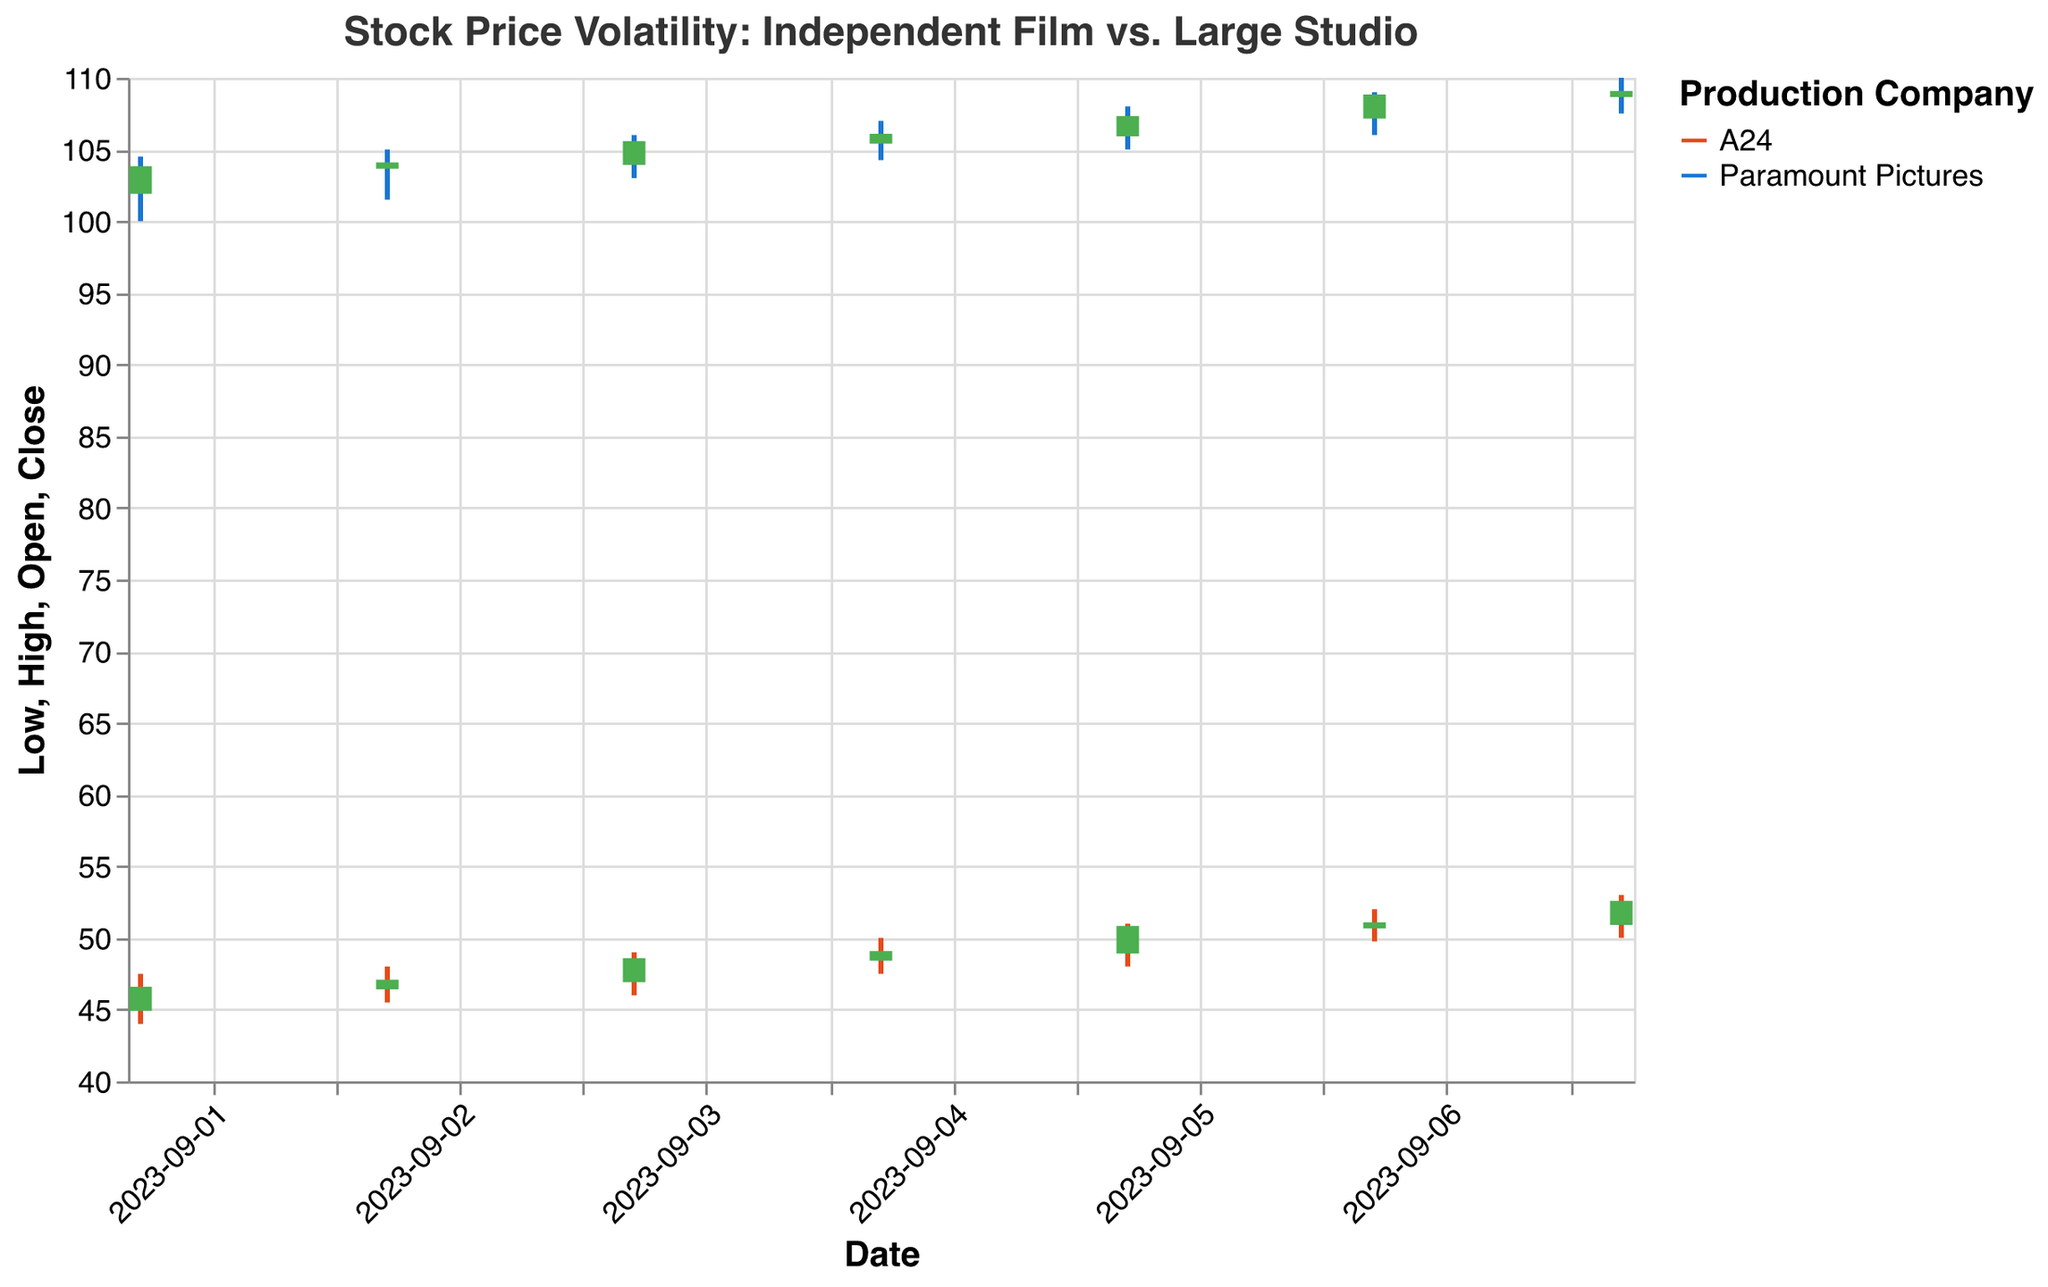How does the title describe the focus of the figure? The title "Stock Price Volatility: Independent Film vs. Large Studio" indicates that the figure compares the stock price fluctuations between an independent film production company (A24) and a large studio (Paramount Pictures).
Answer: Stock Price Volatility: Independent Film vs. Large Studio Which company showed a higher closing price on 2023-09-05? By examining the candlestick for 2023-09-05, A24 had a closing price of 50.75, and Paramount Pictures had a closing price of 107.25.
Answer: Paramount Pictures What was the opening price range for A24 from 2023-09-01 to 2023-09-07? The opening prices for A24 from 2023-09-01 to 2023-09-07 are as follows: 45.00, 46.50, 47.00, 48.50, 49.00, 50.75, 51.00. The range is \(Min=45.00\) and \(Max=51.00\).
Answer: 45.00 to 51.00 Which company had a higher overall price volatility in the period shown? Volatility is indicated by the length of the candlestick wicks. Comparing the lengths of the wicks over the given dates, Paramount Pictures shows generally longer wicks, indicating higher volatility.
Answer: Paramount Pictures How does the average closing price of A24 compare to that of Paramount Pictures over the given period? Calculate the average closing price for A24: \(\frac{46.50+47.00+48.50+49.00+50.75+51.00+52.50}{7} = 49.32\). Calculate the average closing price for Paramount Pictures: \(\frac{103.75+104.00+105.50+106.00+107.25+108.75+109.00}{7} = 106.32\).
Answer: 49.32 for A24 and 106.32 for Paramount Pictures On which date did A24 have its highest closing price, and what was the value? The highest closing price for A24 occurred on 2023-09-07 with a closing price of 52.50.
Answer: 2023-09-07, 52.50 What is the difference between the highest and the lowest prices achieved by Paramount Pictures during the period? The highest price achieved was 110.00 on 2023-09-07 and the lowest price was 100.00 on 2023-09-01. The difference is \(110.00 - 100.00 = 10.00\).
Answer: 10.00 Which company experienced a consistent increase in closing prices over consecutive days, and during which period? A24 had an increasing closing price from 2023-09-01 (46.50) to 2023-09-07 (52.50).
Answer: A24, 2023-09-01 to 2023-09-07 What was the overall trend observed for Paramount Pictures' stock from 2023-09-01 to 2023-09-07? The stock prices for Paramount Pictures showed an upward trend, with increasing closing prices from 103.75 on 2023-09-01 to 109.00 on 2023-09-07.
Answer: Upward trend 